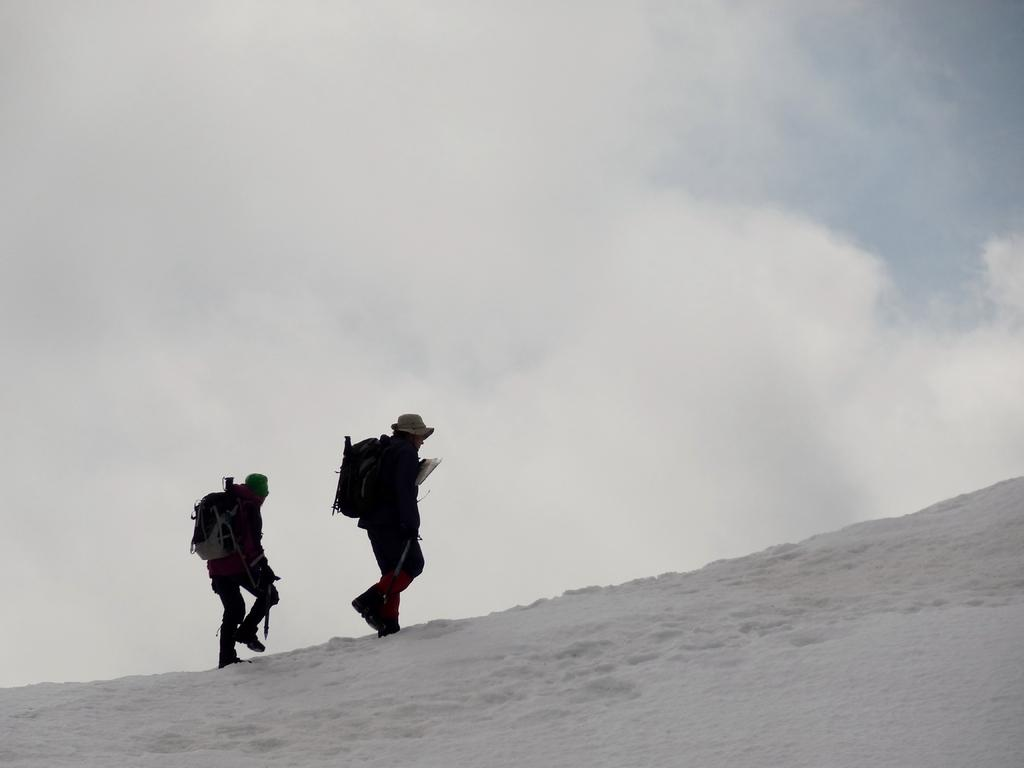What is the setting of the image? The image is an outside view. How many people are in the image? There are two persons in the image. What are the persons wearing on their bodies? The persons are wearing bags and caps on their heads. What is the ground condition in the image? The persons are walking on the snow. What is visible at the top of the image? The sky is visible at the top of the image. What can be seen in the sky? Clouds are present in the sky. What type of brass instrument is being played by the dinosaurs in the image? There are no dinosaurs or brass instruments present in the image. 